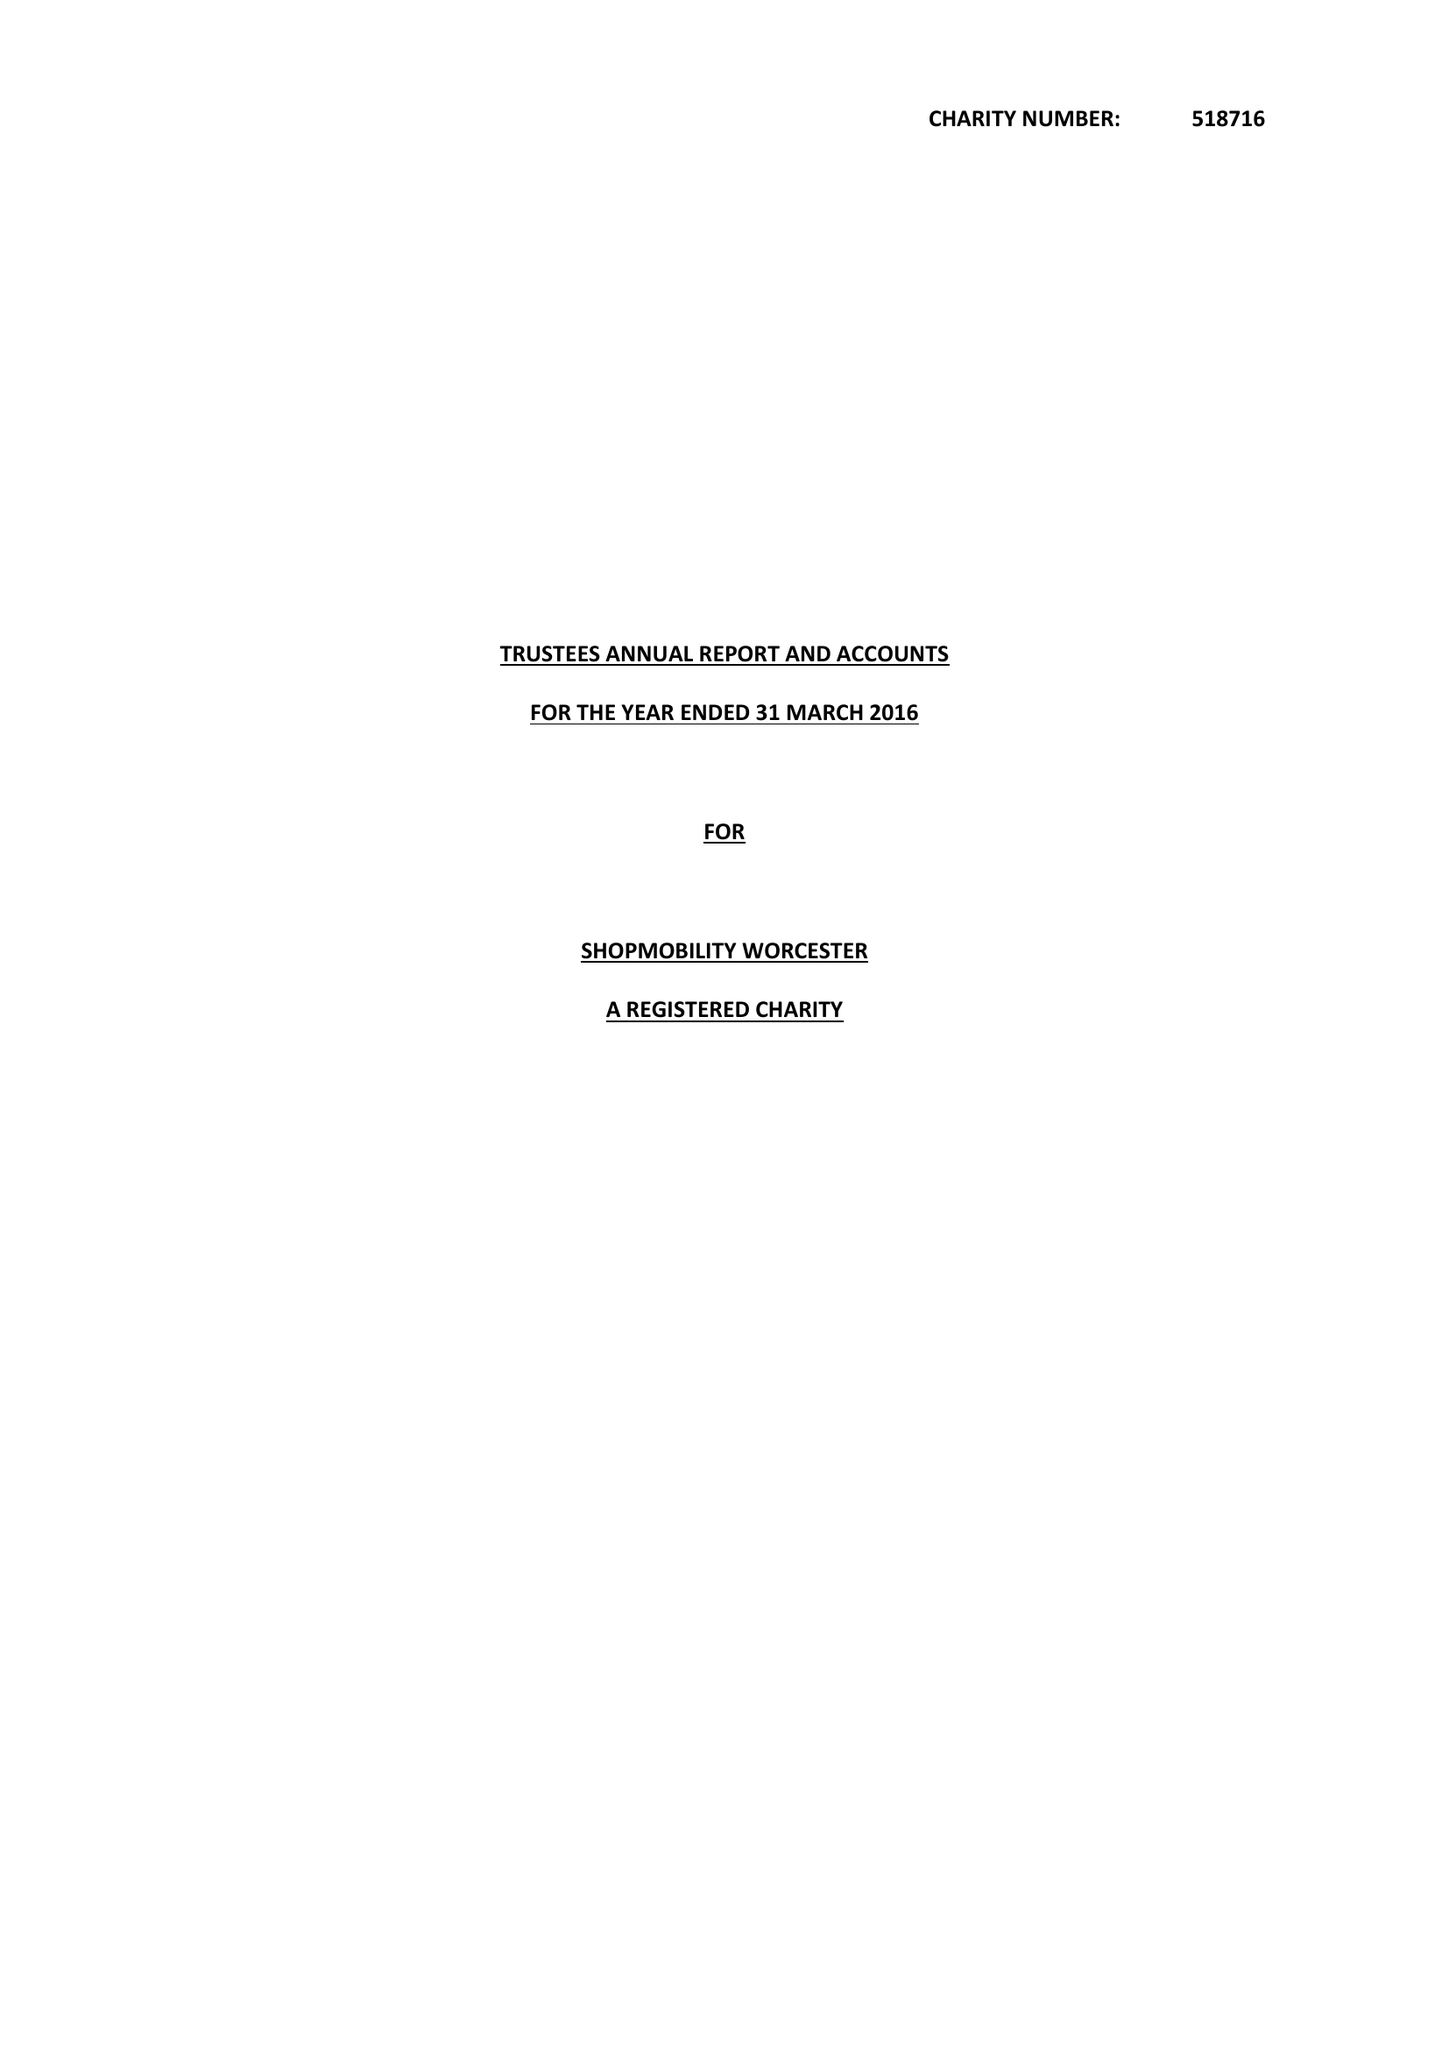What is the value for the charity_number?
Answer the question using a single word or phrase. 518716 